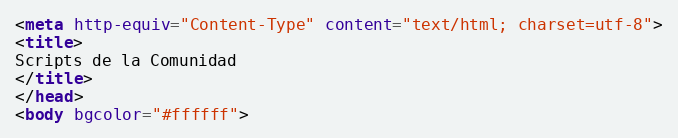Convert code to text. <code><loc_0><loc_0><loc_500><loc_500><_HTML_><meta http-equiv="Content-Type" content="text/html; charset=utf-8">
<title>
Scripts de la Comunidad
</title>
</head>
<body bgcolor="#ffffff"></code> 